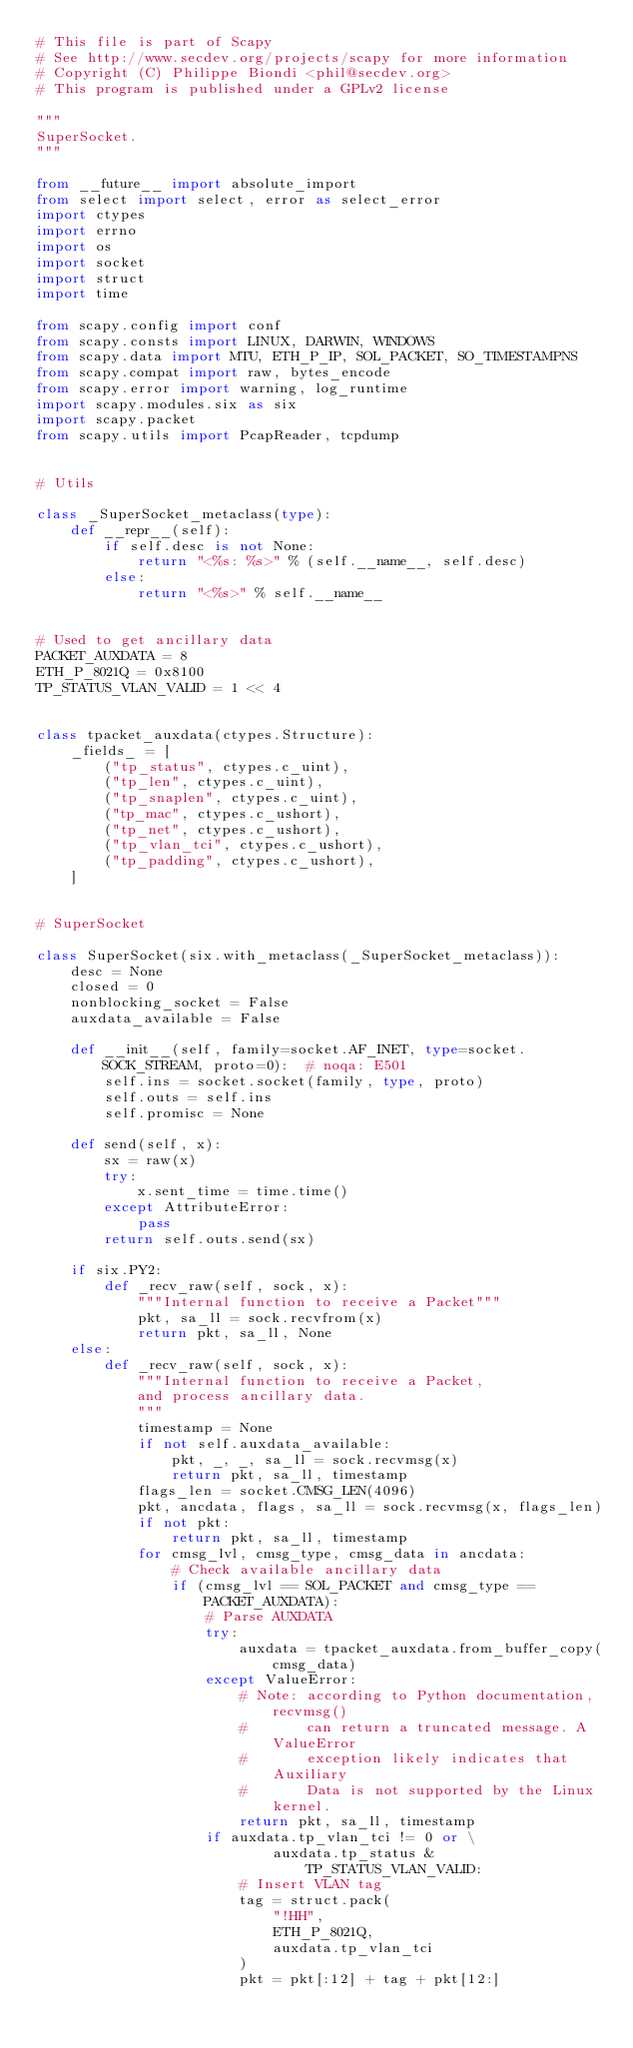Convert code to text. <code><loc_0><loc_0><loc_500><loc_500><_Python_># This file is part of Scapy
# See http://www.secdev.org/projects/scapy for more information
# Copyright (C) Philippe Biondi <phil@secdev.org>
# This program is published under a GPLv2 license

"""
SuperSocket.
"""

from __future__ import absolute_import
from select import select, error as select_error
import ctypes
import errno
import os
import socket
import struct
import time

from scapy.config import conf
from scapy.consts import LINUX, DARWIN, WINDOWS
from scapy.data import MTU, ETH_P_IP, SOL_PACKET, SO_TIMESTAMPNS
from scapy.compat import raw, bytes_encode
from scapy.error import warning, log_runtime
import scapy.modules.six as six
import scapy.packet
from scapy.utils import PcapReader, tcpdump


# Utils

class _SuperSocket_metaclass(type):
    def __repr__(self):
        if self.desc is not None:
            return "<%s: %s>" % (self.__name__, self.desc)
        else:
            return "<%s>" % self.__name__


# Used to get ancillary data
PACKET_AUXDATA = 8
ETH_P_8021Q = 0x8100
TP_STATUS_VLAN_VALID = 1 << 4


class tpacket_auxdata(ctypes.Structure):
    _fields_ = [
        ("tp_status", ctypes.c_uint),
        ("tp_len", ctypes.c_uint),
        ("tp_snaplen", ctypes.c_uint),
        ("tp_mac", ctypes.c_ushort),
        ("tp_net", ctypes.c_ushort),
        ("tp_vlan_tci", ctypes.c_ushort),
        ("tp_padding", ctypes.c_ushort),
    ]


# SuperSocket

class SuperSocket(six.with_metaclass(_SuperSocket_metaclass)):
    desc = None
    closed = 0
    nonblocking_socket = False
    auxdata_available = False

    def __init__(self, family=socket.AF_INET, type=socket.SOCK_STREAM, proto=0):  # noqa: E501
        self.ins = socket.socket(family, type, proto)
        self.outs = self.ins
        self.promisc = None

    def send(self, x):
        sx = raw(x)
        try:
            x.sent_time = time.time()
        except AttributeError:
            pass
        return self.outs.send(sx)

    if six.PY2:
        def _recv_raw(self, sock, x):
            """Internal function to receive a Packet"""
            pkt, sa_ll = sock.recvfrom(x)
            return pkt, sa_ll, None
    else:
        def _recv_raw(self, sock, x):
            """Internal function to receive a Packet,
            and process ancillary data.
            """
            timestamp = None
            if not self.auxdata_available:
                pkt, _, _, sa_ll = sock.recvmsg(x)
                return pkt, sa_ll, timestamp
            flags_len = socket.CMSG_LEN(4096)
            pkt, ancdata, flags, sa_ll = sock.recvmsg(x, flags_len)
            if not pkt:
                return pkt, sa_ll, timestamp
            for cmsg_lvl, cmsg_type, cmsg_data in ancdata:
                # Check available ancillary data
                if (cmsg_lvl == SOL_PACKET and cmsg_type == PACKET_AUXDATA):
                    # Parse AUXDATA
                    try:
                        auxdata = tpacket_auxdata.from_buffer_copy(cmsg_data)
                    except ValueError:
                        # Note: according to Python documentation, recvmsg()
                        #       can return a truncated message. A ValueError
                        #       exception likely indicates that Auxiliary
                        #       Data is not supported by the Linux kernel.
                        return pkt, sa_ll, timestamp
                    if auxdata.tp_vlan_tci != 0 or \
                            auxdata.tp_status & TP_STATUS_VLAN_VALID:
                        # Insert VLAN tag
                        tag = struct.pack(
                            "!HH",
                            ETH_P_8021Q,
                            auxdata.tp_vlan_tci
                        )
                        pkt = pkt[:12] + tag + pkt[12:]</code> 